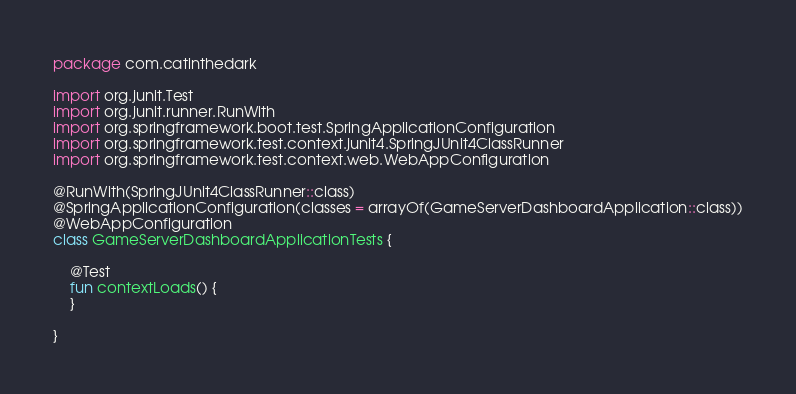<code> <loc_0><loc_0><loc_500><loc_500><_Kotlin_>package com.catinthedark

import org.junit.Test
import org.junit.runner.RunWith
import org.springframework.boot.test.SpringApplicationConfiguration
import org.springframework.test.context.junit4.SpringJUnit4ClassRunner
import org.springframework.test.context.web.WebAppConfiguration

@RunWith(SpringJUnit4ClassRunner::class)
@SpringApplicationConfiguration(classes = arrayOf(GameServerDashboardApplication::class))
@WebAppConfiguration
class GameServerDashboardApplicationTests {

	@Test
	fun contextLoads() {
	}

}
</code> 